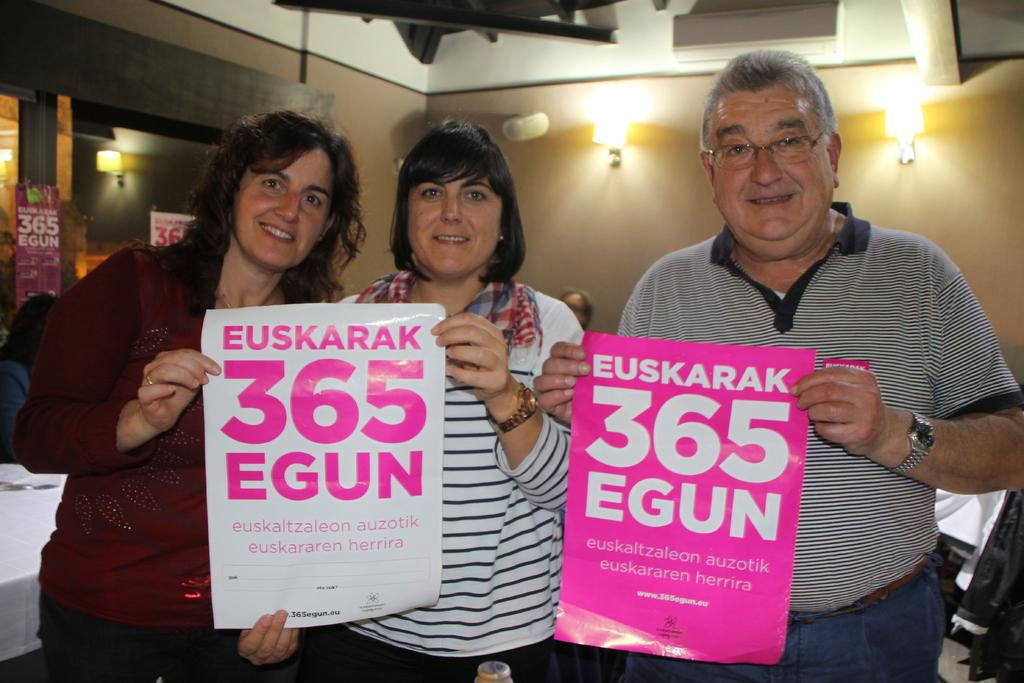How many people are in the image? There are three persons in the image. What are the persons holding in the image? The persons are holding posters. What can be seen in the background of the image? There are clothes, people, posters, lights, glasses, and a wall in the background of the image. What type of fear can be seen on the faces of the persons in the image? There is no indication of fear on the faces of the persons in the image; they are holding posters. How many clocks are visible in the image? There are no clocks visible in the image. 